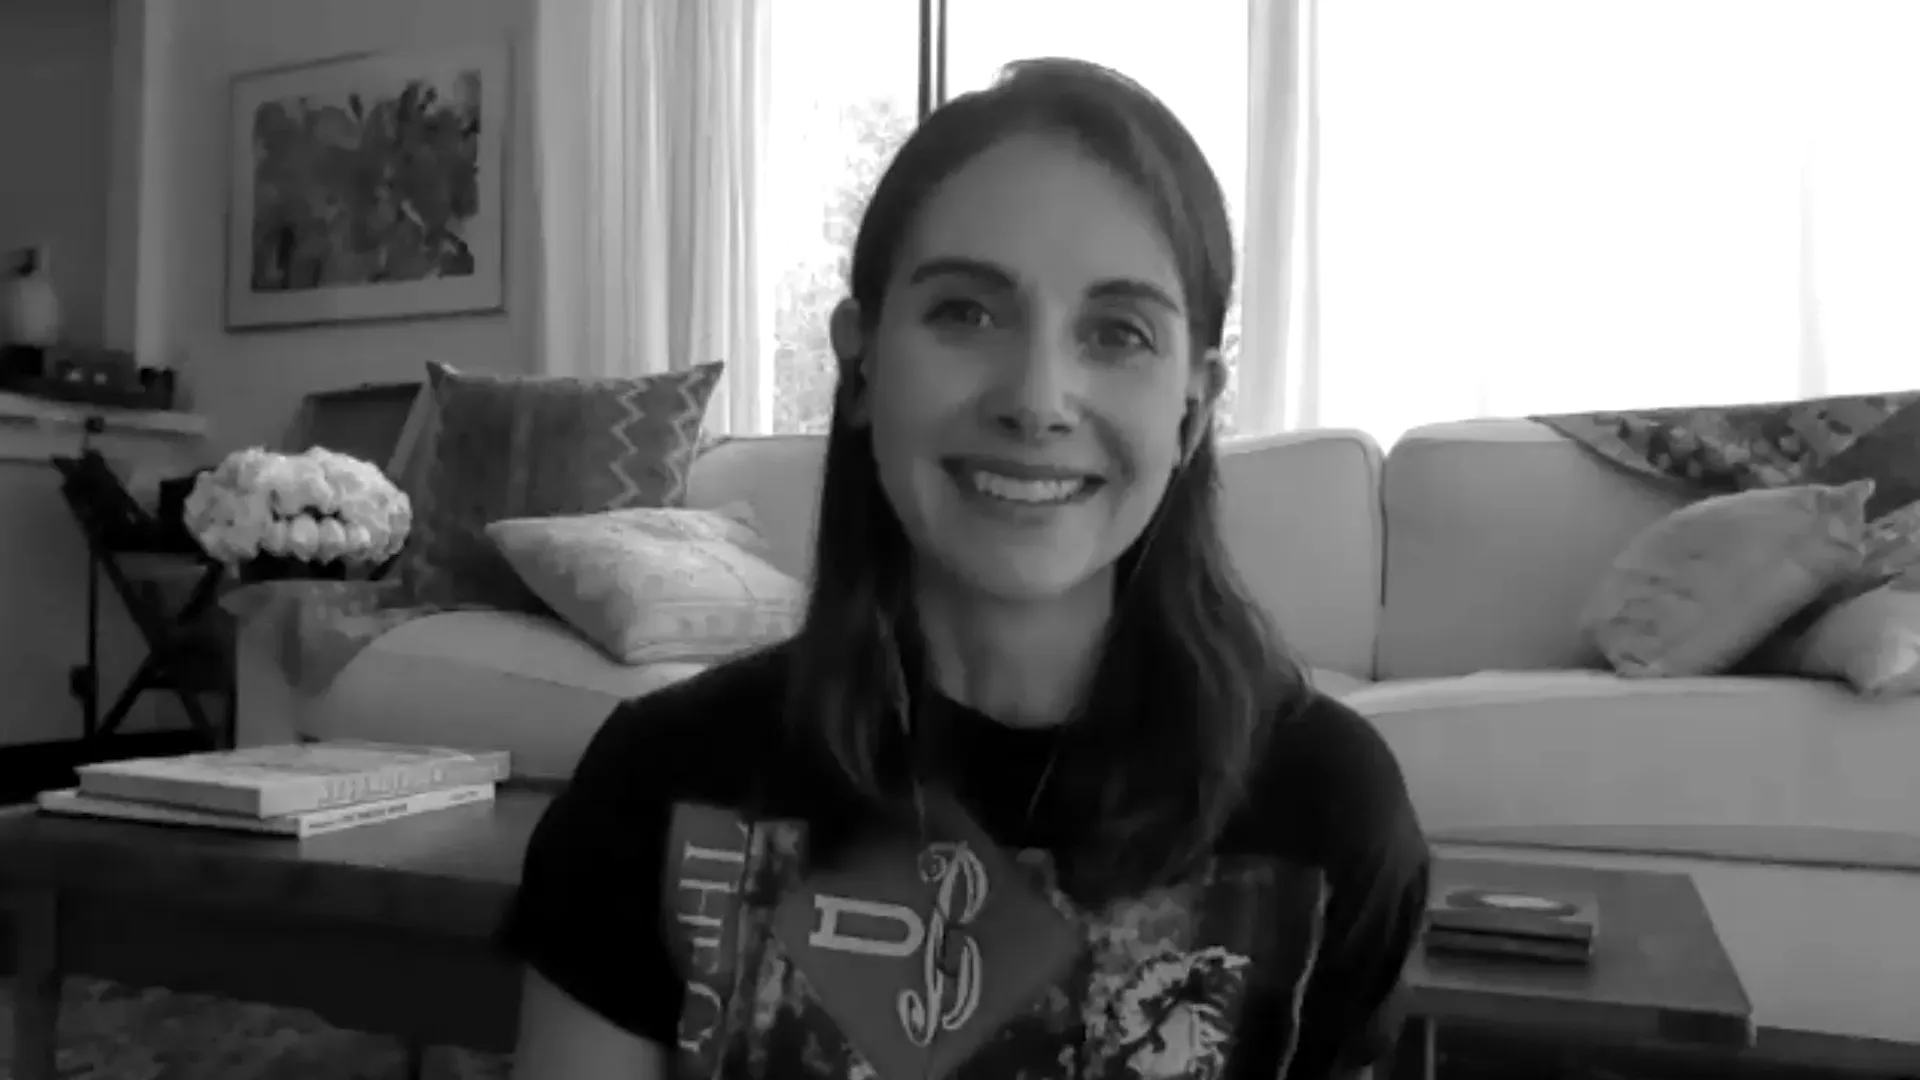What if the woman in the image is actually communicating with someone far away? Imagine that the woman is engaged in a heartfelt video call. Her smile and serene demeanor suggest that she is talking to someone who brings her great joy, possibly a dear friend or a family member she hasn’t seen in a while. The warmth and light filtering into the room reflect the happiness she feels reconnecting, and even through the screen, the connection feels genuine and comforting. 